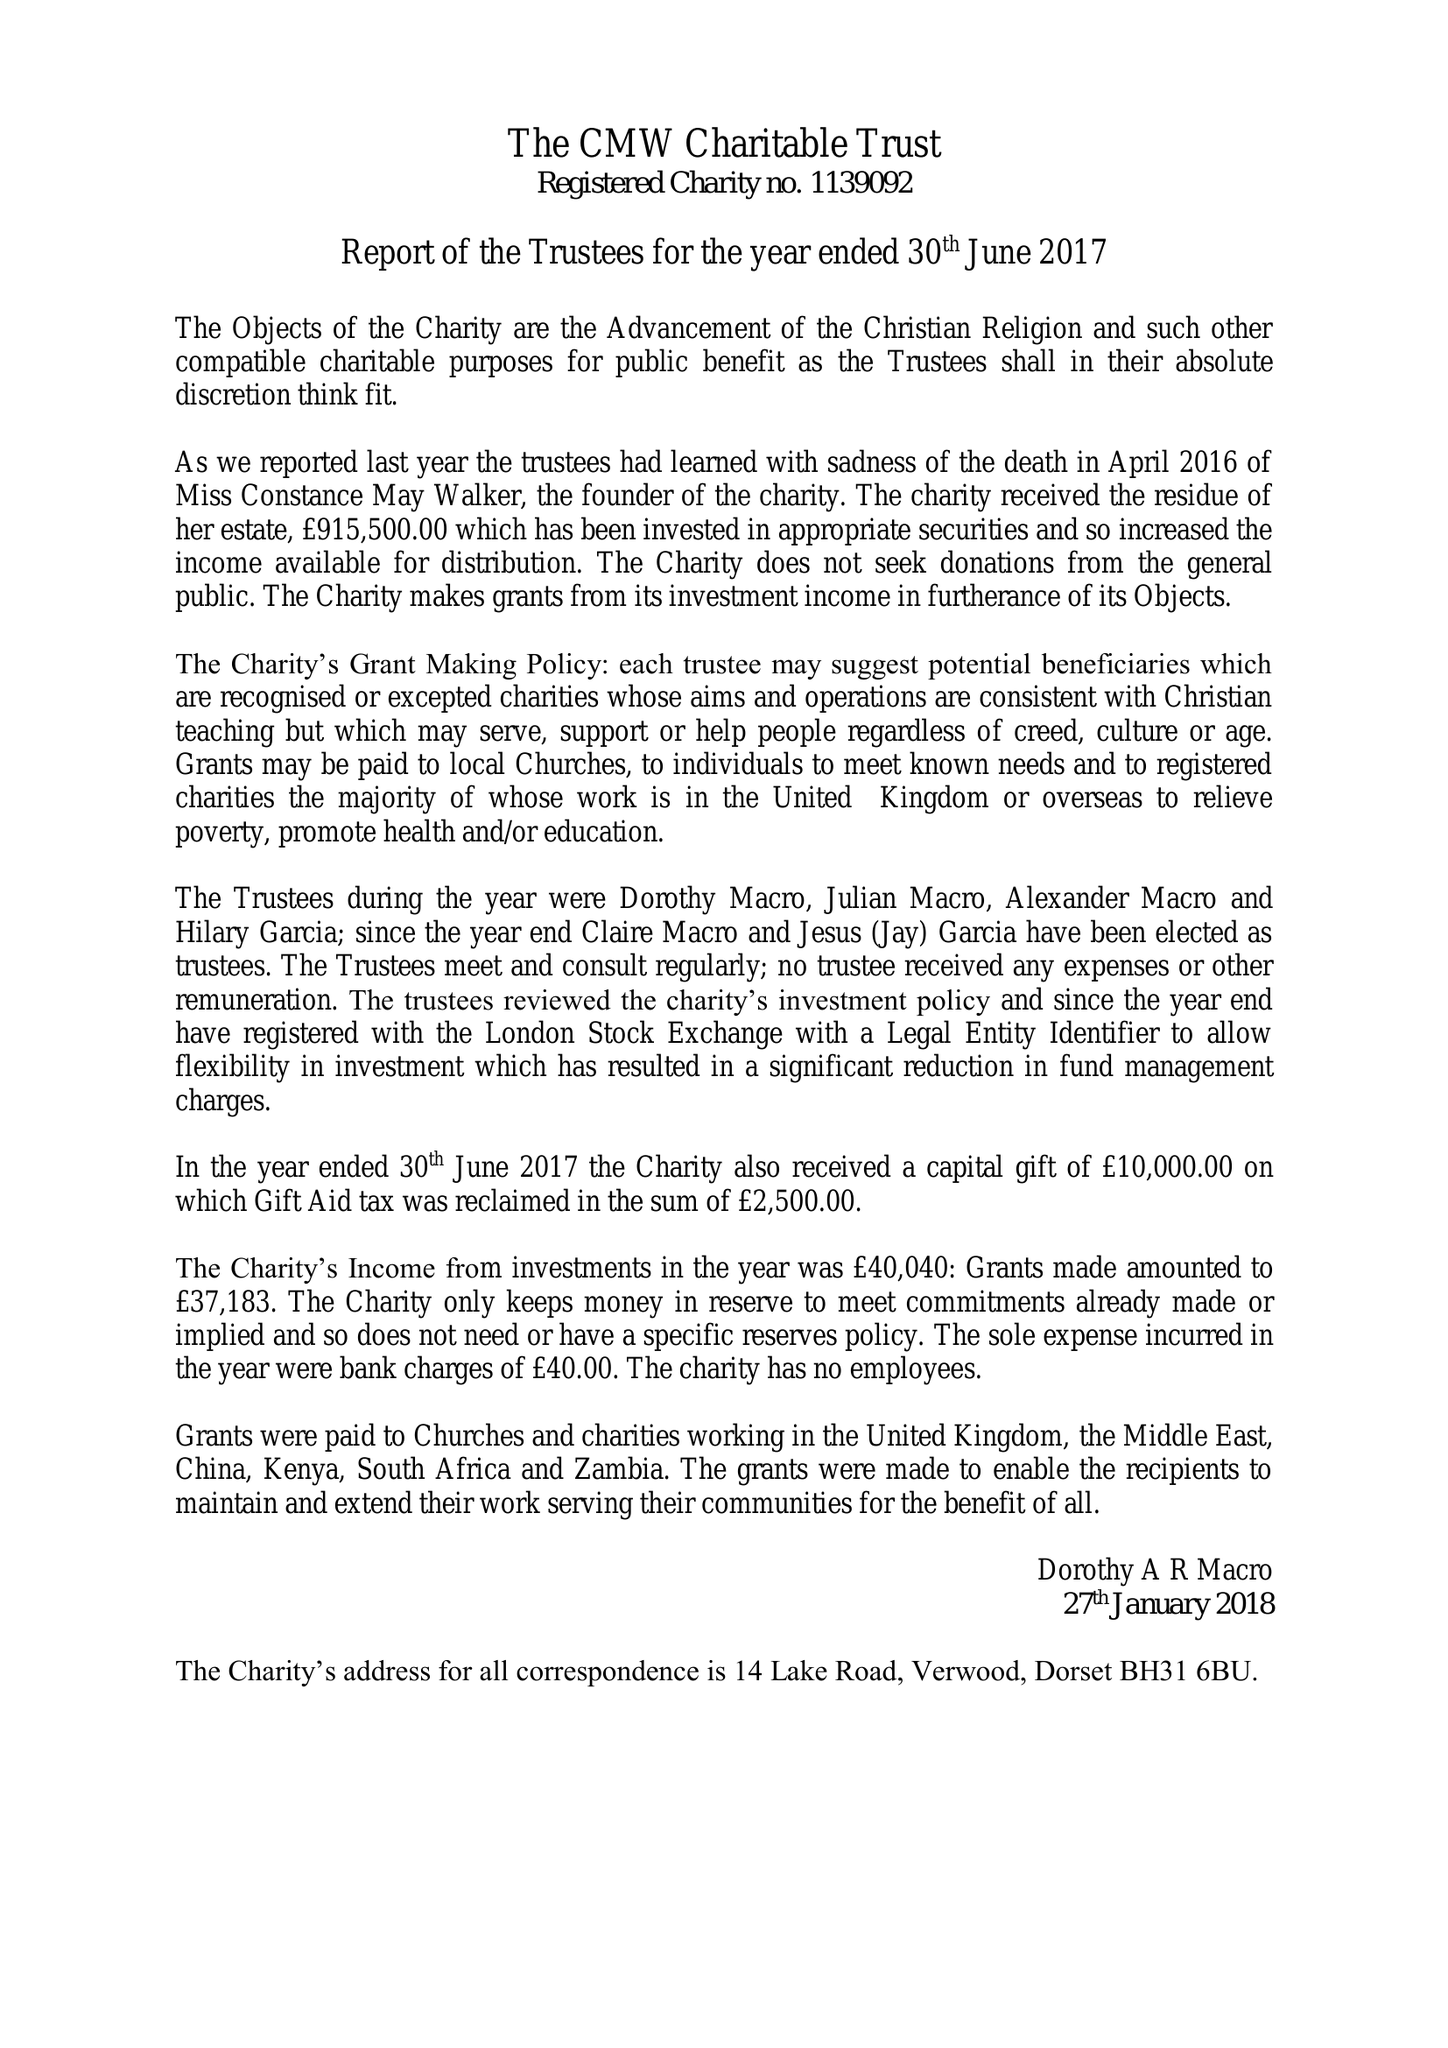What is the value for the charity_number?
Answer the question using a single word or phrase. 1139092 